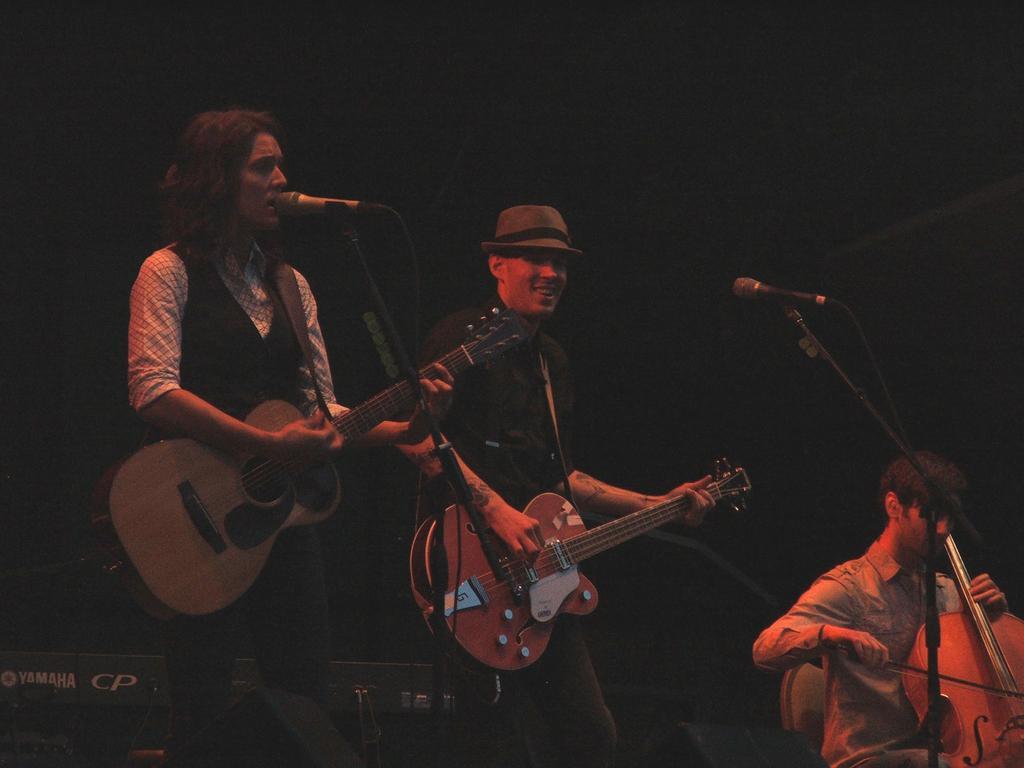Can you describe this image briefly? These 3 people are performing by playing musical instruments and on the left the person is singing also. 